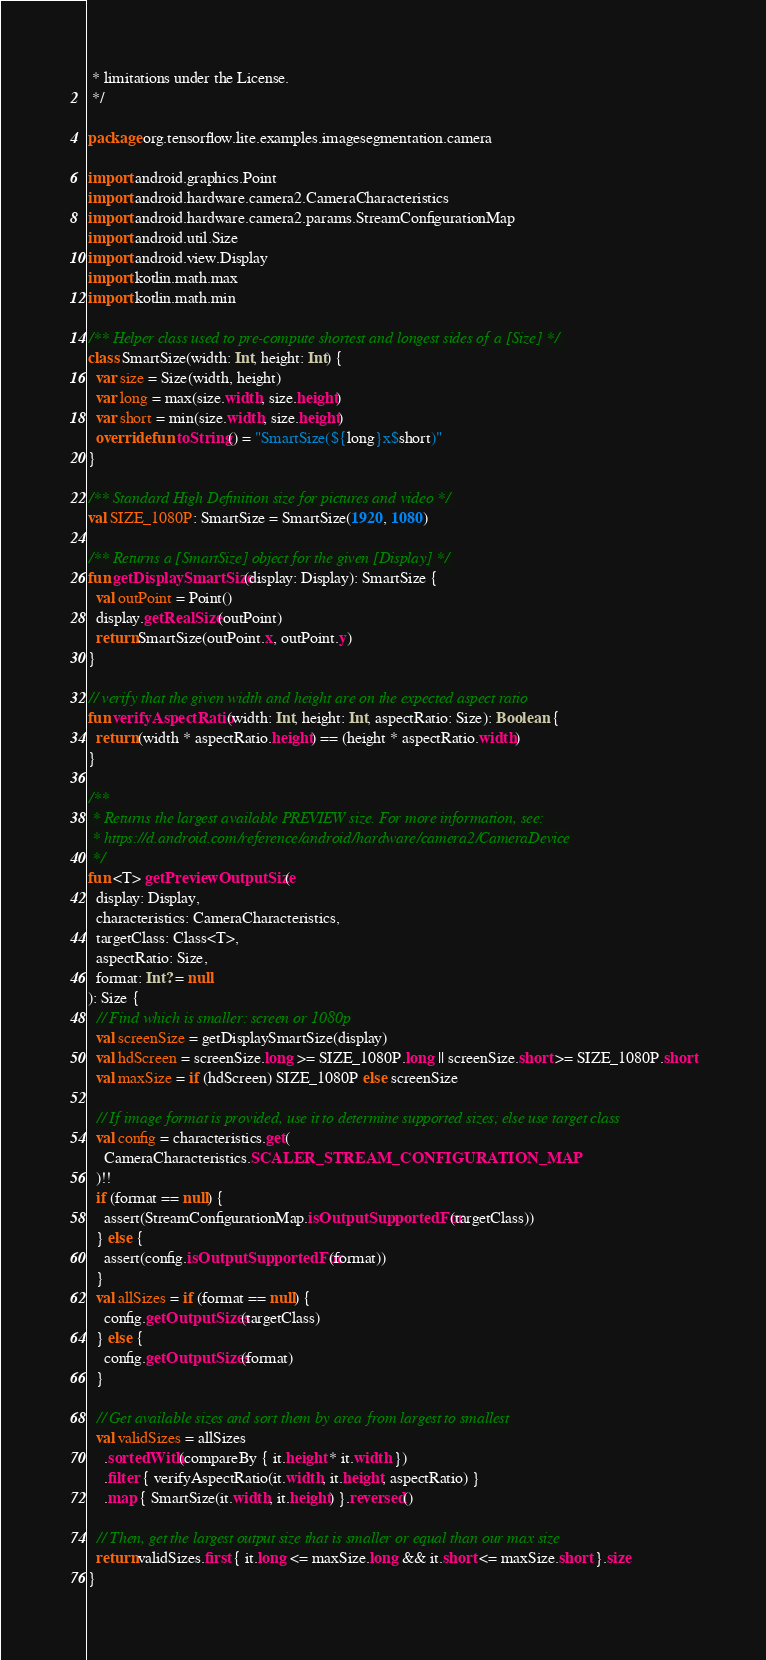<code> <loc_0><loc_0><loc_500><loc_500><_Kotlin_> * limitations under the License.
 */

package org.tensorflow.lite.examples.imagesegmentation.camera

import android.graphics.Point
import android.hardware.camera2.CameraCharacteristics
import android.hardware.camera2.params.StreamConfigurationMap
import android.util.Size
import android.view.Display
import kotlin.math.max
import kotlin.math.min

/** Helper class used to pre-compute shortest and longest sides of a [Size] */
class SmartSize(width: Int, height: Int) {
  var size = Size(width, height)
  var long = max(size.width, size.height)
  var short = min(size.width, size.height)
  override fun toString() = "SmartSize(${long}x$short)"
}

/** Standard High Definition size for pictures and video */
val SIZE_1080P: SmartSize = SmartSize(1920, 1080)

/** Returns a [SmartSize] object for the given [Display] */
fun getDisplaySmartSize(display: Display): SmartSize {
  val outPoint = Point()
  display.getRealSize(outPoint)
  return SmartSize(outPoint.x, outPoint.y)
}

// verify that the given width and height are on the expected aspect ratio
fun verifyAspectRatio(width: Int, height: Int, aspectRatio: Size): Boolean {
  return (width * aspectRatio.height) == (height * aspectRatio.width)
}

/**
 * Returns the largest available PREVIEW size. For more information, see:
 * https://d.android.com/reference/android/hardware/camera2/CameraDevice
 */
fun <T> getPreviewOutputSize(
  display: Display,
  characteristics: CameraCharacteristics,
  targetClass: Class<T>,
  aspectRatio: Size,
  format: Int? = null
): Size {
  // Find which is smaller: screen or 1080p
  val screenSize = getDisplaySmartSize(display)
  val hdScreen = screenSize.long >= SIZE_1080P.long || screenSize.short >= SIZE_1080P.short
  val maxSize = if (hdScreen) SIZE_1080P else screenSize

  // If image format is provided, use it to determine supported sizes; else use target class
  val config = characteristics.get(
    CameraCharacteristics.SCALER_STREAM_CONFIGURATION_MAP
  )!!
  if (format == null) {
    assert(StreamConfigurationMap.isOutputSupportedFor(targetClass))
  } else {
    assert(config.isOutputSupportedFor(format))
  }
  val allSizes = if (format == null) {
    config.getOutputSizes(targetClass)
  } else {
    config.getOutputSizes(format)
  }

  // Get available sizes and sort them by area from largest to smallest
  val validSizes = allSizes
    .sortedWith(compareBy { it.height * it.width })
    .filter { verifyAspectRatio(it.width, it.height, aspectRatio) }
    .map { SmartSize(it.width, it.height) }.reversed()

  // Then, get the largest output size that is smaller or equal than our max size
  return validSizes.first { it.long <= maxSize.long && it.short <= maxSize.short }.size
}
</code> 